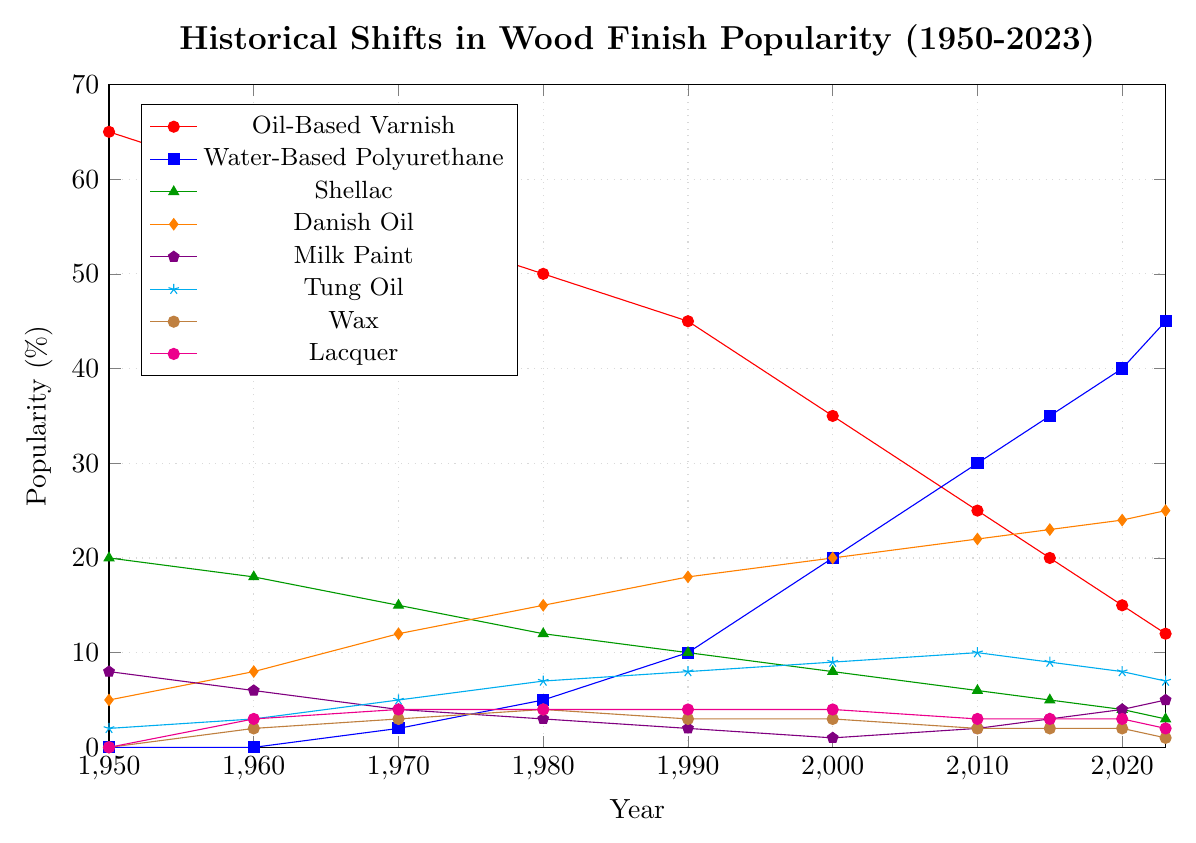What is the most popular wood finish in 1950? To determine the most popular wood finish in 1950, check the figure and find the highest percentage along the y-axis for the year 1950. The "Oil-Based Varnish" line is the highest.
Answer: Oil-Based Varnish How did the popularity of Water-Based Polyurethane change between 1970 and 2023? Examine the figure to find the points representing Water-Based Polyurethane for 1970 and 2023. Notice that it increased from 2% to 45%.
Answer: Increased by 43% Which wood finish had the greatest increase in popularity from 1950 to 2023? Compare the percentage changes for all wood finishes between 1950 and 2023. Water-Based Polyurethane increased from 0% to 45%, the highest increase.
Answer: Water-Based Polyurethane In which year did Danish Oil first surpass Shellac in popularity? Look at the intersection points of the Danish Oil line and Shellac line. The intersection first occurs between 1960 and 1970. Check exact values; Danish Oil surpasses Shellac in 1970.
Answer: 1970 Which wood finishes maintain a relatively constant popularity trend over the years? Observe the figure for finishes with nearly straight lines with minimal slope. Lacquer and Wax have relatively constant trends over the years.
Answer: Lacquer and Wax How much more popular was Oil-Based Varnish compared to Water-Based Polyurethane in 1980? Identify the points for Oil-Based Varnish and Water-Based Polyurethane in 1980. Subtract Water-Based Polyurethane's percentage from Oil-Based Varnish's. 50% - 5% = 45%.
Answer: 45% What is the average popularity of Tung Oil from 1950 to 2023? Sum the values of Tung Oil from all the specified years and divide by the number of years (10). (2 + 3 + 5 + 7 + 8 + 9 + 10 + 9 + 8 + 7) / 10 = 68 / 10 = 6.8.
Answer: 6.8% Which wood finish shows a decline in popularity from 1950 to 2023? Compare the starting and ending points for all wood finishes. Oil-Based Varnish shows a noticeable decline from 65% in 1950 to 12% in 2023.
Answer: Oil-Based Varnish What is the sum of the popularity percentages for Milk Paint in 1950 and 2023? Add the popularity percentages for Milk Paint in 1950 and 2023 from the figure. 8% (1950) + 5% (2023) = 13%.
Answer: 13% Between which years did Milk Paint have its lowest popularity percentage? Find the year with the lowest point on the Milk Paint line. From the figure, it appears lowest at 1% in 2000.
Answer: 2000 